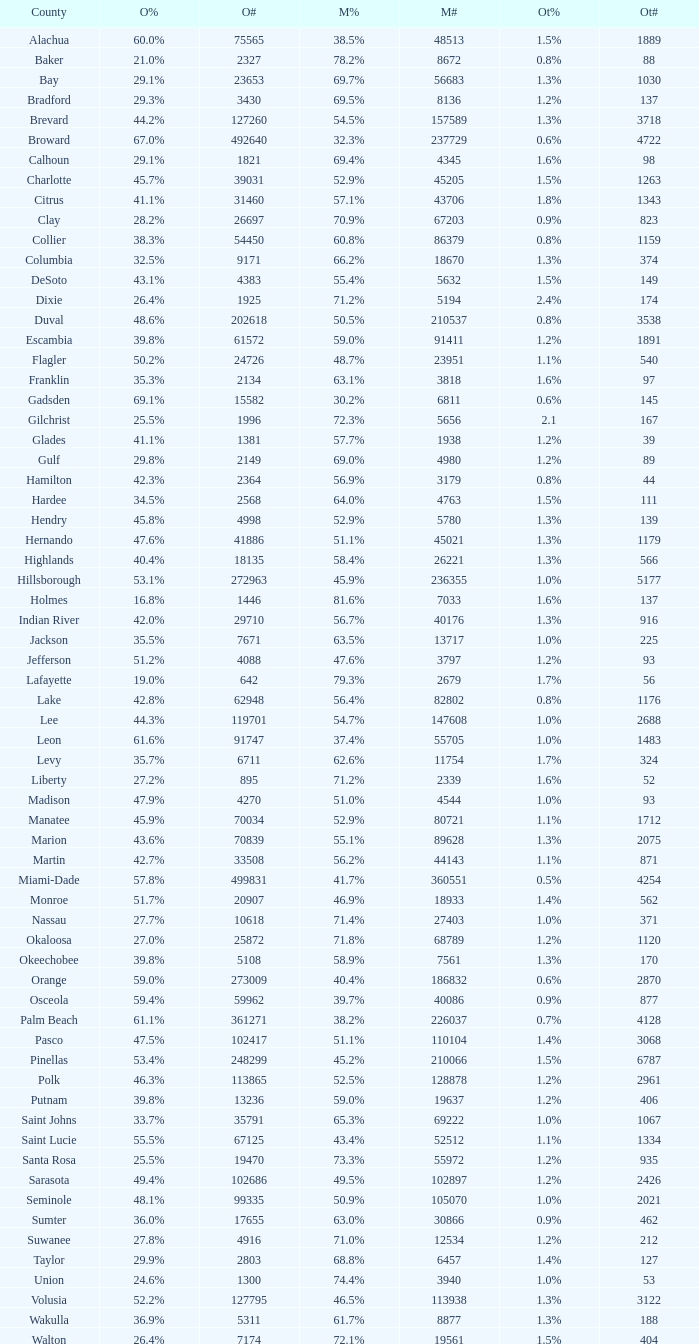0 voters? 1.3%. 